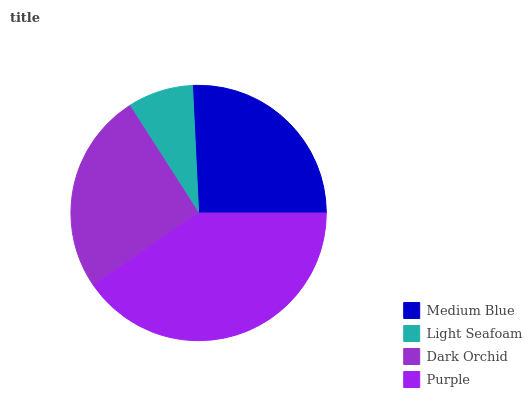Is Light Seafoam the minimum?
Answer yes or no. Yes. Is Purple the maximum?
Answer yes or no. Yes. Is Dark Orchid the minimum?
Answer yes or no. No. Is Dark Orchid the maximum?
Answer yes or no. No. Is Dark Orchid greater than Light Seafoam?
Answer yes or no. Yes. Is Light Seafoam less than Dark Orchid?
Answer yes or no. Yes. Is Light Seafoam greater than Dark Orchid?
Answer yes or no. No. Is Dark Orchid less than Light Seafoam?
Answer yes or no. No. Is Medium Blue the high median?
Answer yes or no. Yes. Is Dark Orchid the low median?
Answer yes or no. Yes. Is Purple the high median?
Answer yes or no. No. Is Light Seafoam the low median?
Answer yes or no. No. 